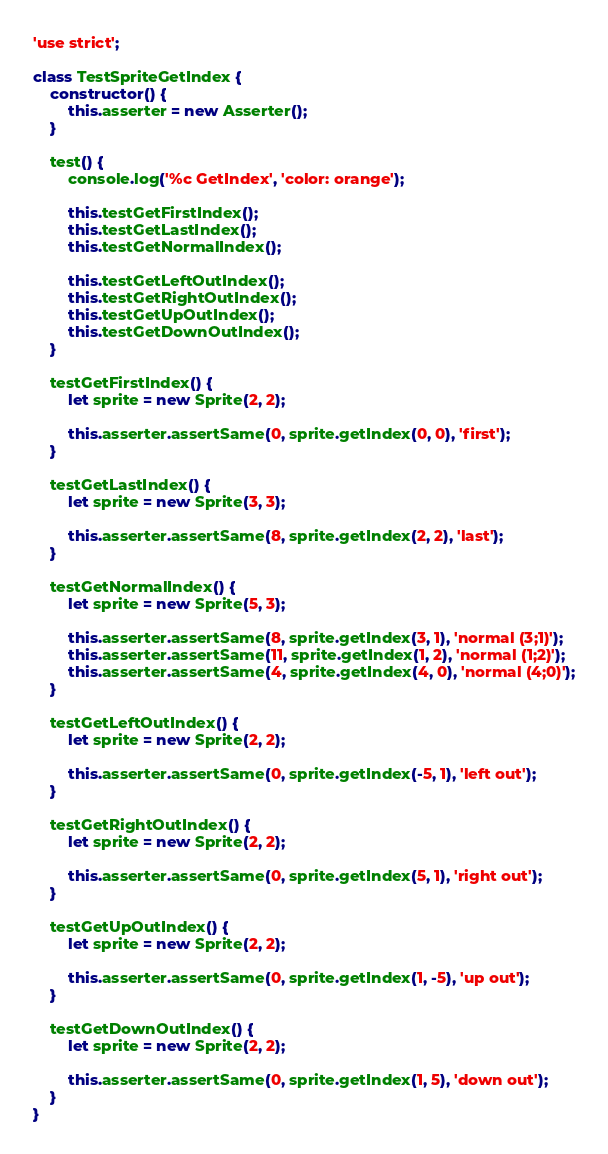Convert code to text. <code><loc_0><loc_0><loc_500><loc_500><_JavaScript_>'use strict';

class TestSpriteGetIndex {
	constructor() {
		this.asserter = new Asserter();
	}
	
	test() {
		console.log('%c GetIndex', 'color: orange');

		this.testGetFirstIndex();
		this.testGetLastIndex();
		this.testGetNormalIndex();

		this.testGetLeftOutIndex();
		this.testGetRightOutIndex();
		this.testGetUpOutIndex();
		this.testGetDownOutIndex();
	}

	testGetFirstIndex() {
		let sprite = new Sprite(2, 2);

		this.asserter.assertSame(0, sprite.getIndex(0, 0), 'first');
	}

	testGetLastIndex() {
		let sprite = new Sprite(3, 3);

		this.asserter.assertSame(8, sprite.getIndex(2, 2), 'last');
	}

	testGetNormalIndex() {
		let sprite = new Sprite(5, 3);

		this.asserter.assertSame(8, sprite.getIndex(3, 1), 'normal (3;1)');
		this.asserter.assertSame(11, sprite.getIndex(1, 2), 'normal (1;2)');
		this.asserter.assertSame(4, sprite.getIndex(4, 0), 'normal (4;0)');
	}

	testGetLeftOutIndex() {
		let sprite = new Sprite(2, 2);

		this.asserter.assertSame(0, sprite.getIndex(-5, 1), 'left out');
	}

	testGetRightOutIndex() {
		let sprite = new Sprite(2, 2);

		this.asserter.assertSame(0, sprite.getIndex(5, 1), 'right out');
	}

	testGetUpOutIndex() {
		let sprite = new Sprite(2, 2);

		this.asserter.assertSame(0, sprite.getIndex(1, -5), 'up out');
	}
	
	testGetDownOutIndex() {
		let sprite = new Sprite(2, 2);

		this.asserter.assertSame(0, sprite.getIndex(1, 5), 'down out');
	}
}
</code> 